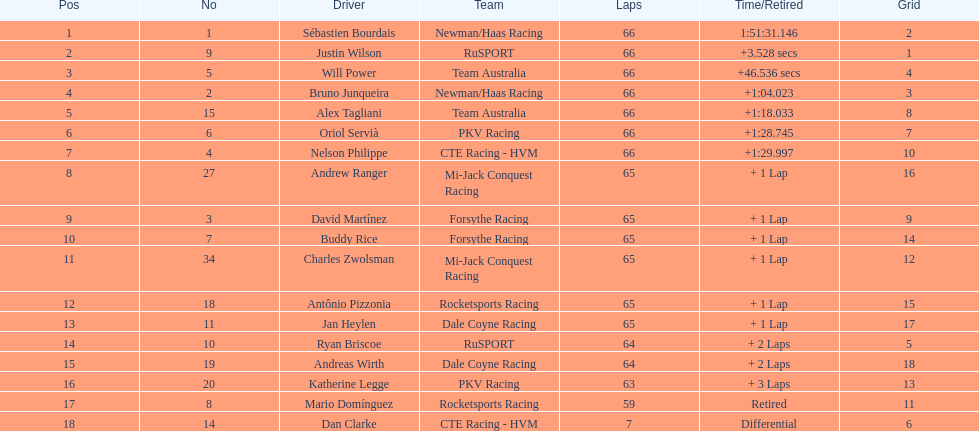Who finished directly after the driver who finished in 1:28.745? Nelson Philippe. 